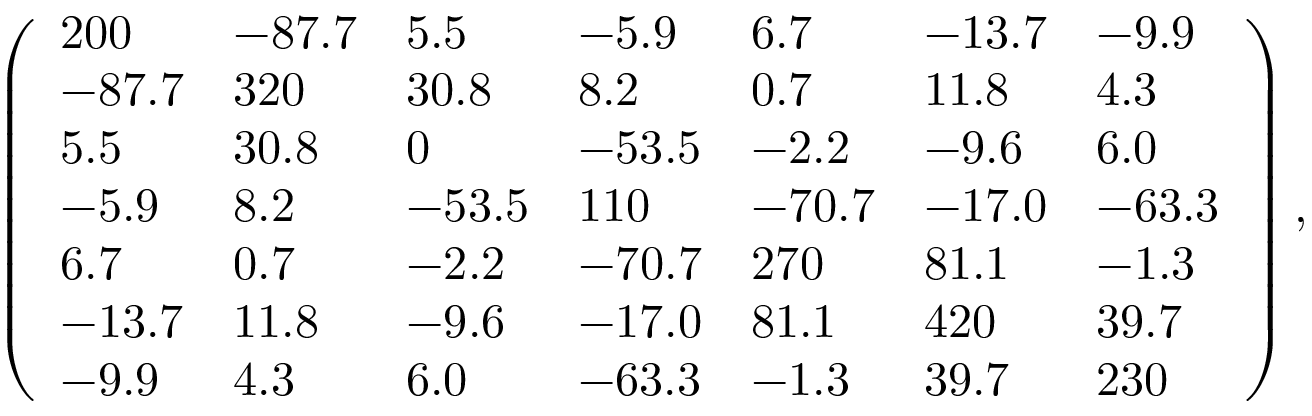<formula> <loc_0><loc_0><loc_500><loc_500>\left ( \begin{array} { l l l l l l l } { 2 0 0 } & { - 8 7 . 7 } & { 5 . 5 } & { - 5 . 9 } & { 6 . 7 } & { - 1 3 . 7 } & { - 9 . 9 } \\ { - 8 7 . 7 } & { 3 2 0 } & { 3 0 . 8 } & { 8 . 2 } & { 0 . 7 } & { 1 1 . 8 } & { 4 . 3 } \\ { 5 . 5 } & { 3 0 . 8 } & { 0 } & { - 5 3 . 5 } & { - 2 . 2 } & { - 9 . 6 } & { 6 . 0 } \\ { - 5 . 9 } & { 8 . 2 } & { - 5 3 . 5 } & { 1 1 0 } & { - 7 0 . 7 } & { - 1 7 . 0 } & { - 6 3 . 3 } \\ { 6 . 7 } & { 0 . 7 } & { - 2 . 2 } & { - 7 0 . 7 } & { 2 7 0 } & { 8 1 . 1 } & { - 1 . 3 } \\ { - 1 3 . 7 } & { 1 1 . 8 } & { - 9 . 6 } & { - 1 7 . 0 } & { 8 1 . 1 } & { 4 2 0 } & { 3 9 . 7 } \\ { - 9 . 9 } & { 4 . 3 } & { 6 . 0 } & { - 6 3 . 3 } & { - 1 . 3 } & { 3 9 . 7 } & { 2 3 0 } \end{array} \right ) ,</formula> 